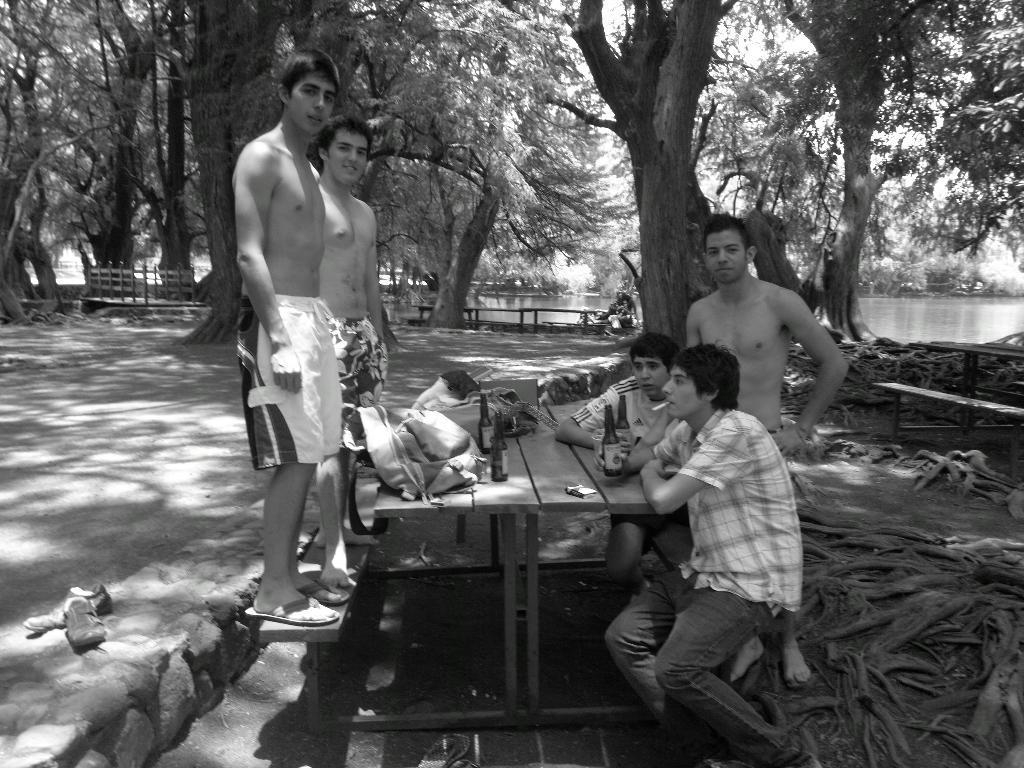Describe this image in one or two sentences. It is a black and white picture group of people are sitting around the table there are few bottles on the table in the background there are lot of trees fencing, behind it there is a lake. 